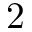<formula> <loc_0><loc_0><loc_500><loc_500>2</formula> 